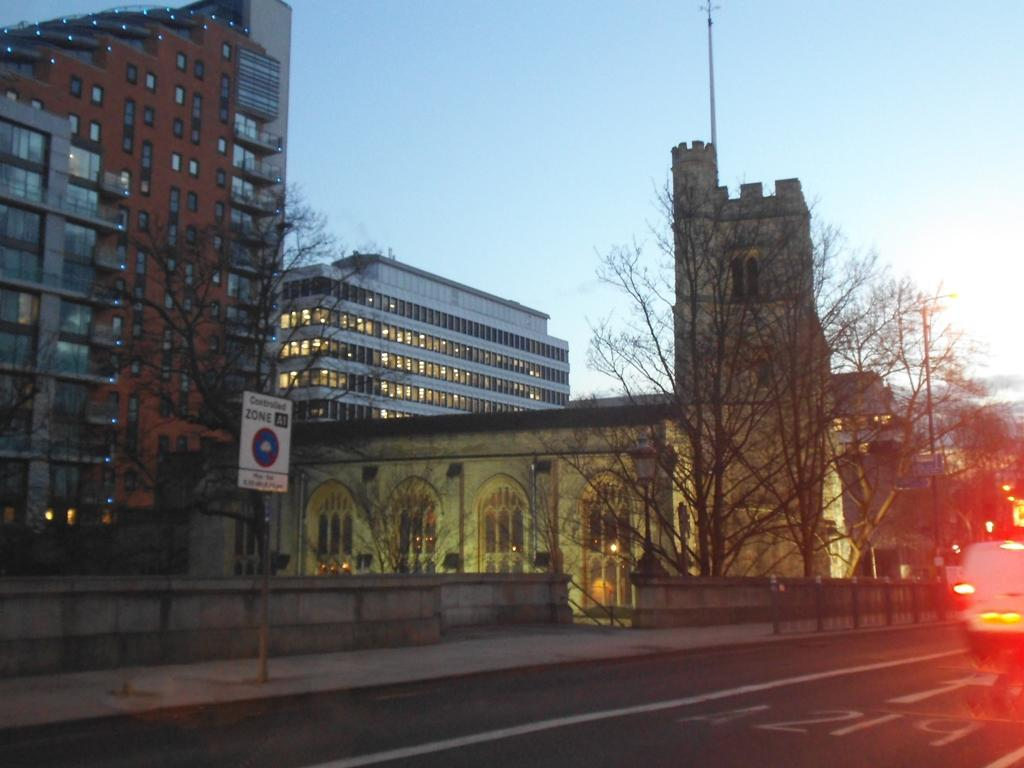What type of structures can be seen in the image? There are buildings with windows in the image. What other elements are present in the image besides buildings? There are trees, a signboard, a vehicle on the road, and the sky is visible in the background. What type of plantation can be seen in the image? There is no plantation present in the image. What type of crack is visible on the vehicle in the image? There is no crack visible on the vehicle in the image. 